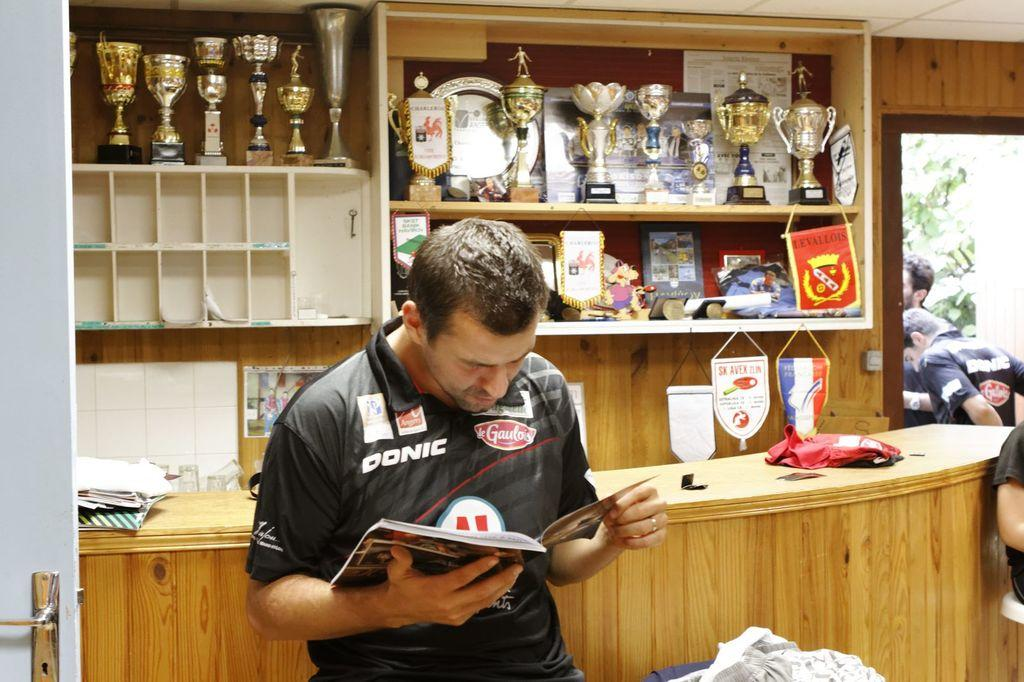<image>
Offer a succinct explanation of the picture presented. A man is reading a magazine in front of the counter wearing a DONIC shirt 